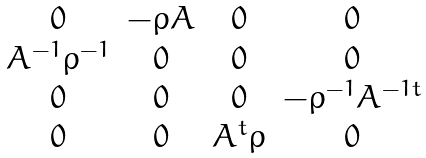Convert formula to latex. <formula><loc_0><loc_0><loc_500><loc_500>\begin{matrix} 0 & - \rho A & 0 & 0 \\ A ^ { - 1 } \rho ^ { - 1 } & 0 & 0 & 0 \\ 0 & 0 & 0 & - \rho ^ { - 1 } A ^ { - 1 t } \\ 0 & 0 & A ^ { t } \rho & 0 \end{matrix}</formula> 